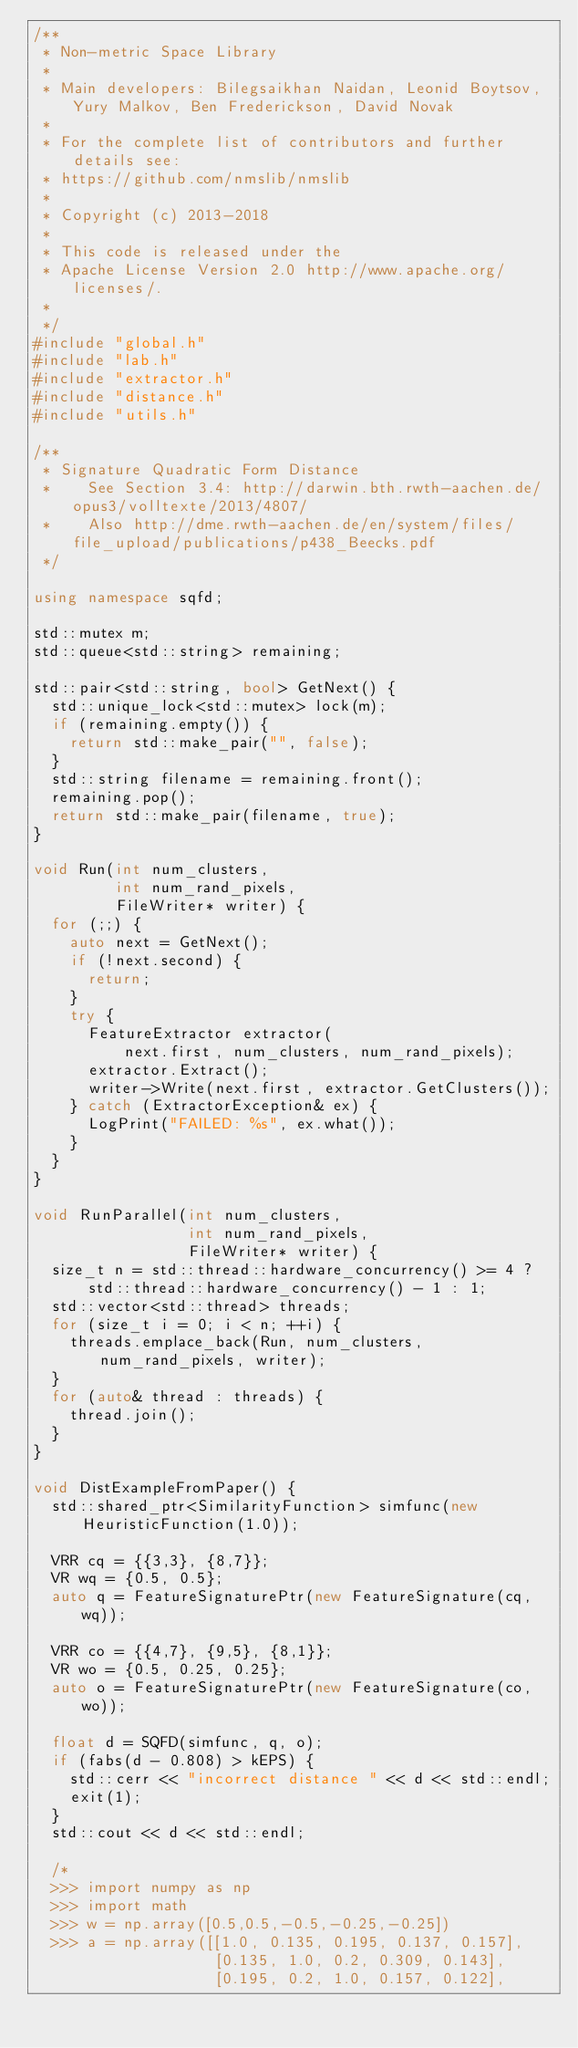Convert code to text. <code><loc_0><loc_0><loc_500><loc_500><_C++_>/**
 * Non-metric Space Library
 *
 * Main developers: Bilegsaikhan Naidan, Leonid Boytsov, Yury Malkov, Ben Frederickson, David Novak
 *
 * For the complete list of contributors and further details see:
 * https://github.com/nmslib/nmslib
 *
 * Copyright (c) 2013-2018
 *
 * This code is released under the
 * Apache License Version 2.0 http://www.apache.org/licenses/.
 *
 */
#include "global.h"
#include "lab.h"
#include "extractor.h"
#include "distance.h"
#include "utils.h"

/**
 * Signature Quadratic Form Distance
 *    See Section 3.4: http://darwin.bth.rwth-aachen.de/opus3/volltexte/2013/4807/
 *    Also http://dme.rwth-aachen.de/en/system/files/file_upload/publications/p438_Beecks.pdf
 */

using namespace sqfd;

std::mutex m;
std::queue<std::string> remaining;

std::pair<std::string, bool> GetNext() {
  std::unique_lock<std::mutex> lock(m);
  if (remaining.empty()) {
    return std::make_pair("", false);
  }
  std::string filename = remaining.front();
  remaining.pop();
  return std::make_pair(filename, true);
}

void Run(int num_clusters,
         int num_rand_pixels,
         FileWriter* writer) {
  for (;;) {
    auto next = GetNext();
    if (!next.second) {
      return;
    }
    try {
      FeatureExtractor extractor(
          next.first, num_clusters, num_rand_pixels);
      extractor.Extract();
      writer->Write(next.first, extractor.GetClusters());
    } catch (ExtractorException& ex) {
      LogPrint("FAILED: %s", ex.what());
    }
  }
}

void RunParallel(int num_clusters,
                 int num_rand_pixels,
                 FileWriter* writer) {
  size_t n = std::thread::hardware_concurrency() >= 4 ?
      std::thread::hardware_concurrency() - 1 : 1;
  std::vector<std::thread> threads;
  for (size_t i = 0; i < n; ++i) {
    threads.emplace_back(Run, num_clusters, num_rand_pixels, writer);
  }
  for (auto& thread : threads) {
    thread.join();
  }
}

void DistExampleFromPaper() {
  std::shared_ptr<SimilarityFunction> simfunc(new HeuristicFunction(1.0));

  VRR cq = {{3,3}, {8,7}};
  VR wq = {0.5, 0.5};
  auto q = FeatureSignaturePtr(new FeatureSignature(cq, wq));

  VRR co = {{4,7}, {9,5}, {8,1}};
  VR wo = {0.5, 0.25, 0.25};
  auto o = FeatureSignaturePtr(new FeatureSignature(co, wo));

  float d = SQFD(simfunc, q, o);
  if (fabs(d - 0.808) > kEPS) {
    std::cerr << "incorrect distance " << d << std::endl;
    exit(1);
  }
  std::cout << d << std::endl;

  /*
  >>> import numpy as np
  >>> import math
  >>> w = np.array([0.5,0.5,-0.5,-0.25,-0.25])
  >>> a = np.array([[1.0, 0.135, 0.195, 0.137, 0.157],
                    [0.135, 1.0, 0.2, 0.309, 0.143],
                    [0.195, 0.2, 1.0, 0.157, 0.122],</code> 